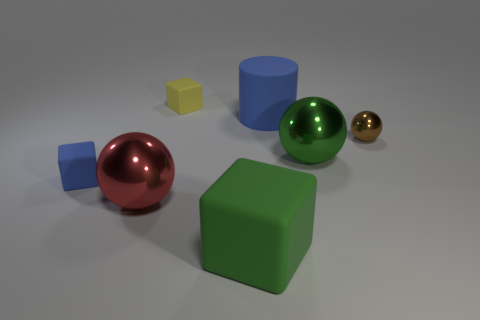Are there any large red metal balls in front of the big green block?
Provide a succinct answer. No. What is the size of the rubber block that is behind the blue thing that is in front of the green metal sphere?
Make the answer very short. Small. Is the number of brown spheres to the left of the big green rubber block the same as the number of metal things in front of the blue cube?
Offer a very short reply. No. There is a large green matte block to the right of the yellow rubber block; are there any cylinders in front of it?
Make the answer very short. No. How many matte blocks are behind the big green object that is to the left of the blue object on the right side of the big red shiny ball?
Make the answer very short. 2. Are there fewer yellow blocks than big gray things?
Ensure brevity in your answer.  No. Does the small object that is on the right side of the large cylinder have the same shape as the small matte object on the left side of the yellow matte thing?
Provide a succinct answer. No. What color is the big matte cube?
Keep it short and to the point. Green. What number of shiny objects are either brown things or purple balls?
Your response must be concise. 1. What is the color of the other tiny shiny thing that is the same shape as the green metallic object?
Keep it short and to the point. Brown. 